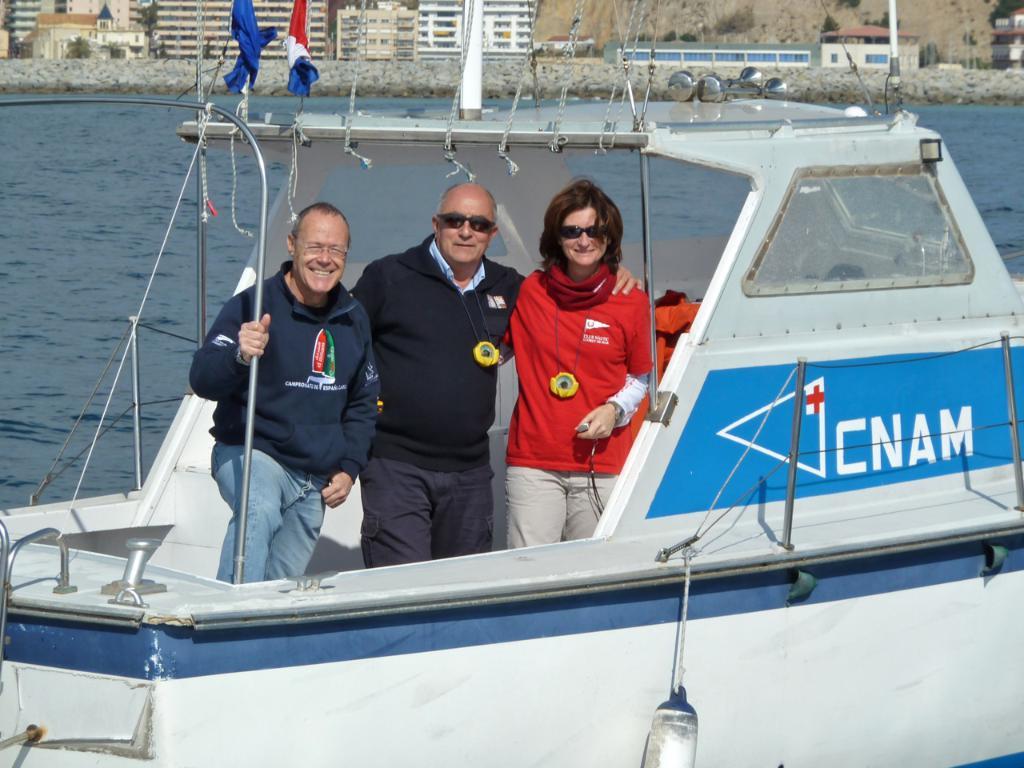What is the name on the boat?
Offer a very short reply. Cnam. 